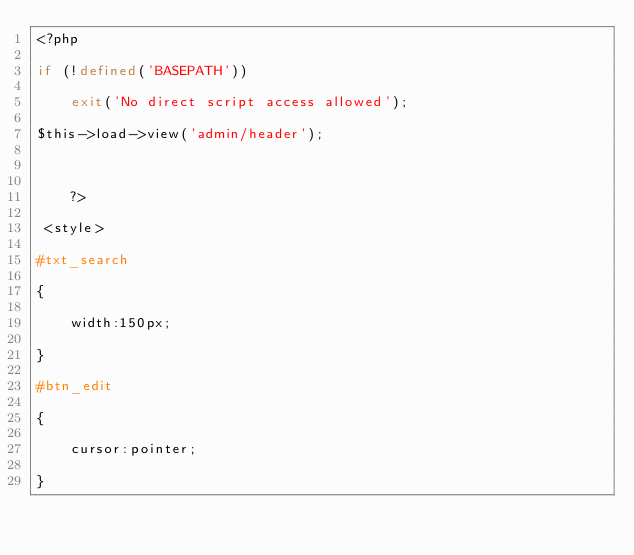<code> <loc_0><loc_0><loc_500><loc_500><_PHP_><?php

if (!defined('BASEPATH'))

    exit('No direct script access allowed');

$this->load->view('admin/header');



	?>

 <style> 

#txt_search

{

	width:150px;

} 

#btn_edit

{

	cursor:pointer;

}
</code> 